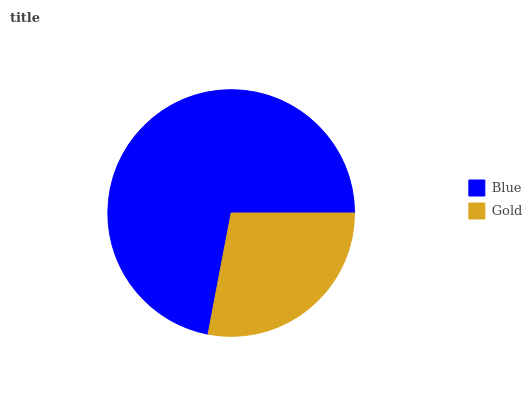Is Gold the minimum?
Answer yes or no. Yes. Is Blue the maximum?
Answer yes or no. Yes. Is Gold the maximum?
Answer yes or no. No. Is Blue greater than Gold?
Answer yes or no. Yes. Is Gold less than Blue?
Answer yes or no. Yes. Is Gold greater than Blue?
Answer yes or no. No. Is Blue less than Gold?
Answer yes or no. No. Is Blue the high median?
Answer yes or no. Yes. Is Gold the low median?
Answer yes or no. Yes. Is Gold the high median?
Answer yes or no. No. Is Blue the low median?
Answer yes or no. No. 